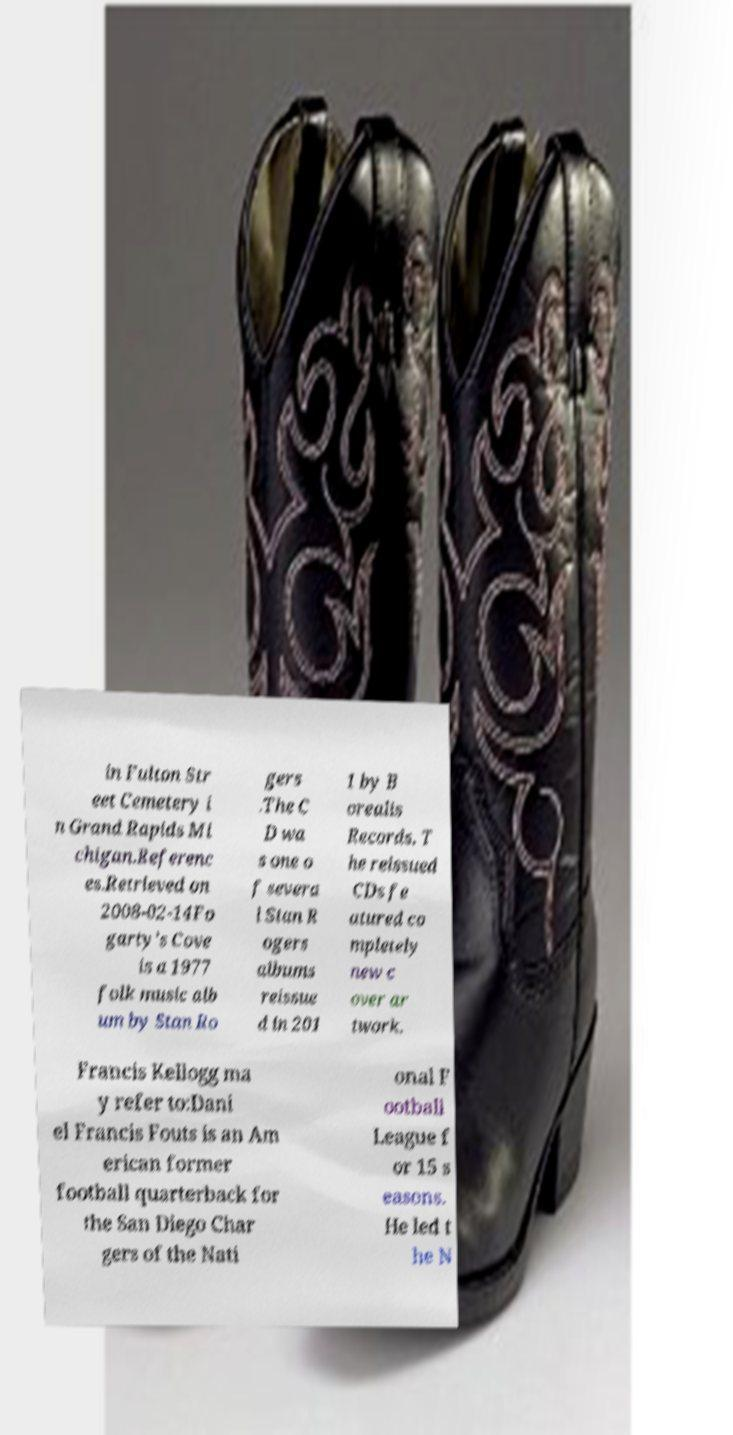Can you read and provide the text displayed in the image?This photo seems to have some interesting text. Can you extract and type it out for me? in Fulton Str eet Cemetery i n Grand Rapids Mi chigan.Referenc es.Retrieved on 2008-02-14Fo garty's Cove is a 1977 folk music alb um by Stan Ro gers .The C D wa s one o f severa l Stan R ogers albums reissue d in 201 1 by B orealis Records. T he reissued CDs fe atured co mpletely new c over ar twork. Francis Kellogg ma y refer to:Dani el Francis Fouts is an Am erican former football quarterback for the San Diego Char gers of the Nati onal F ootball League f or 15 s easons. He led t he N 